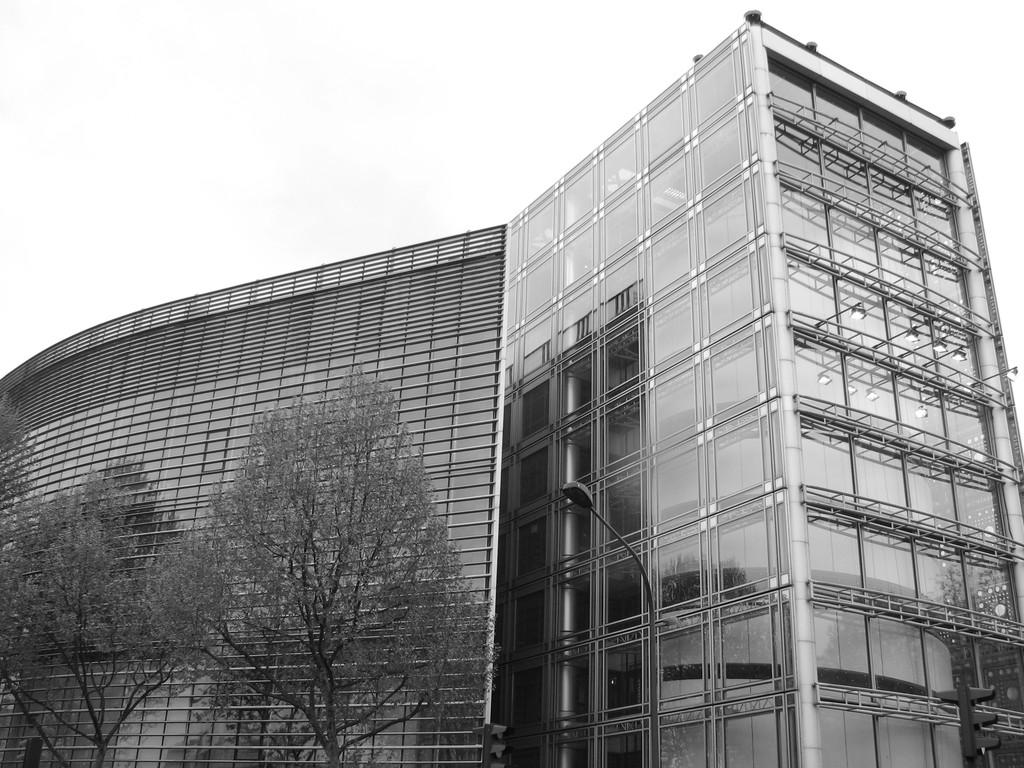What type of structure is visible in the image? There is a building with windows in the image. What can be seen on the right side of the image? There are trees and a signal pole on the right side of the image. What is the condition of the sky in the image? The sky is clear in the image. Where are the toys located in the image? There are no toys present in the image. What type of hose can be seen connected to the building in the image? There is no hose connected to the building in the image. 